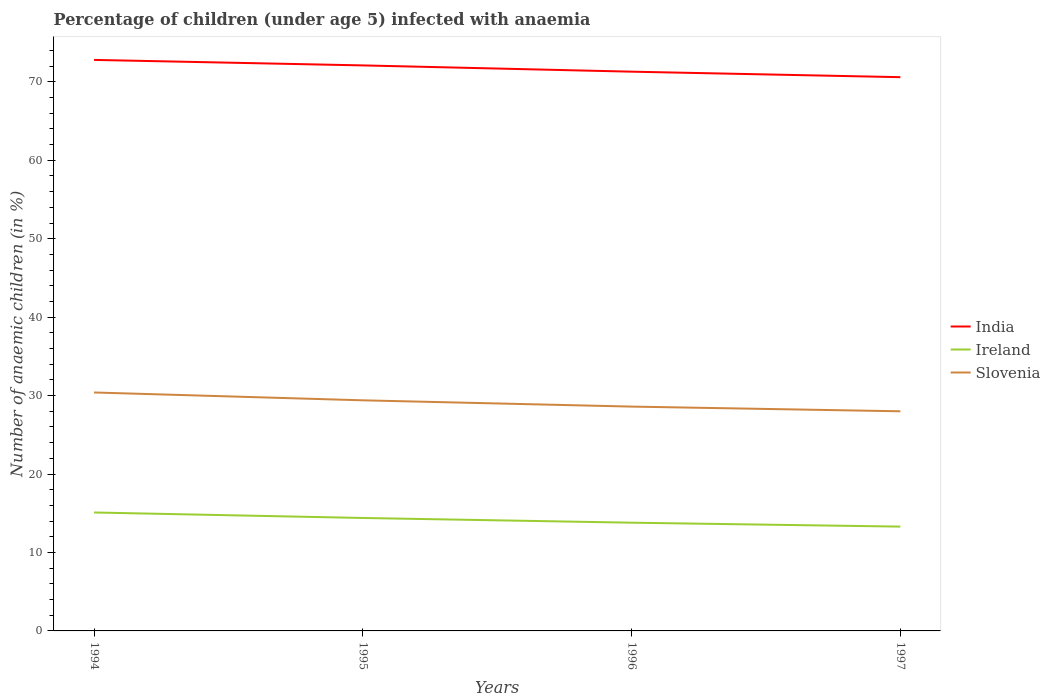How many different coloured lines are there?
Your response must be concise. 3. Does the line corresponding to India intersect with the line corresponding to Ireland?
Offer a very short reply. No. Across all years, what is the maximum percentage of children infected with anaemia in in Slovenia?
Make the answer very short. 28. In which year was the percentage of children infected with anaemia in in Ireland maximum?
Provide a succinct answer. 1997. What is the total percentage of children infected with anaemia in in India in the graph?
Make the answer very short. 0.7. What is the difference between the highest and the second highest percentage of children infected with anaemia in in Slovenia?
Ensure brevity in your answer.  2.4. Is the percentage of children infected with anaemia in in India strictly greater than the percentage of children infected with anaemia in in Ireland over the years?
Offer a very short reply. No. How many lines are there?
Offer a terse response. 3. How many years are there in the graph?
Your response must be concise. 4. Are the values on the major ticks of Y-axis written in scientific E-notation?
Keep it short and to the point. No. Does the graph contain grids?
Give a very brief answer. No. Where does the legend appear in the graph?
Your response must be concise. Center right. What is the title of the graph?
Provide a succinct answer. Percentage of children (under age 5) infected with anaemia. Does "Afghanistan" appear as one of the legend labels in the graph?
Give a very brief answer. No. What is the label or title of the Y-axis?
Give a very brief answer. Number of anaemic children (in %). What is the Number of anaemic children (in %) of India in 1994?
Your answer should be compact. 72.8. What is the Number of anaemic children (in %) in Ireland in 1994?
Offer a very short reply. 15.1. What is the Number of anaemic children (in %) in Slovenia in 1994?
Your response must be concise. 30.4. What is the Number of anaemic children (in %) in India in 1995?
Ensure brevity in your answer.  72.1. What is the Number of anaemic children (in %) of Ireland in 1995?
Provide a short and direct response. 14.4. What is the Number of anaemic children (in %) in Slovenia in 1995?
Your answer should be very brief. 29.4. What is the Number of anaemic children (in %) of India in 1996?
Your answer should be very brief. 71.3. What is the Number of anaemic children (in %) of Slovenia in 1996?
Offer a very short reply. 28.6. What is the Number of anaemic children (in %) of India in 1997?
Ensure brevity in your answer.  70.6. Across all years, what is the maximum Number of anaemic children (in %) of India?
Your answer should be compact. 72.8. Across all years, what is the maximum Number of anaemic children (in %) of Ireland?
Offer a terse response. 15.1. Across all years, what is the maximum Number of anaemic children (in %) in Slovenia?
Keep it short and to the point. 30.4. Across all years, what is the minimum Number of anaemic children (in %) of India?
Your answer should be very brief. 70.6. Across all years, what is the minimum Number of anaemic children (in %) of Ireland?
Your response must be concise. 13.3. Across all years, what is the minimum Number of anaemic children (in %) of Slovenia?
Ensure brevity in your answer.  28. What is the total Number of anaemic children (in %) of India in the graph?
Ensure brevity in your answer.  286.8. What is the total Number of anaemic children (in %) of Ireland in the graph?
Provide a succinct answer. 56.6. What is the total Number of anaemic children (in %) of Slovenia in the graph?
Keep it short and to the point. 116.4. What is the difference between the Number of anaemic children (in %) of Ireland in 1994 and that in 1995?
Provide a succinct answer. 0.7. What is the difference between the Number of anaemic children (in %) of Slovenia in 1994 and that in 1995?
Keep it short and to the point. 1. What is the difference between the Number of anaemic children (in %) in Slovenia in 1994 and that in 1997?
Provide a succinct answer. 2.4. What is the difference between the Number of anaemic children (in %) of Ireland in 1995 and that in 1996?
Provide a short and direct response. 0.6. What is the difference between the Number of anaemic children (in %) in Slovenia in 1995 and that in 1996?
Provide a short and direct response. 0.8. What is the difference between the Number of anaemic children (in %) of India in 1995 and that in 1997?
Keep it short and to the point. 1.5. What is the difference between the Number of anaemic children (in %) of Slovenia in 1995 and that in 1997?
Offer a terse response. 1.4. What is the difference between the Number of anaemic children (in %) in India in 1996 and that in 1997?
Provide a succinct answer. 0.7. What is the difference between the Number of anaemic children (in %) in Ireland in 1996 and that in 1997?
Make the answer very short. 0.5. What is the difference between the Number of anaemic children (in %) of Slovenia in 1996 and that in 1997?
Offer a very short reply. 0.6. What is the difference between the Number of anaemic children (in %) in India in 1994 and the Number of anaemic children (in %) in Ireland in 1995?
Keep it short and to the point. 58.4. What is the difference between the Number of anaemic children (in %) of India in 1994 and the Number of anaemic children (in %) of Slovenia in 1995?
Offer a very short reply. 43.4. What is the difference between the Number of anaemic children (in %) of Ireland in 1994 and the Number of anaemic children (in %) of Slovenia in 1995?
Ensure brevity in your answer.  -14.3. What is the difference between the Number of anaemic children (in %) of India in 1994 and the Number of anaemic children (in %) of Ireland in 1996?
Your response must be concise. 59. What is the difference between the Number of anaemic children (in %) of India in 1994 and the Number of anaemic children (in %) of Slovenia in 1996?
Your response must be concise. 44.2. What is the difference between the Number of anaemic children (in %) of India in 1994 and the Number of anaemic children (in %) of Ireland in 1997?
Offer a terse response. 59.5. What is the difference between the Number of anaemic children (in %) of India in 1994 and the Number of anaemic children (in %) of Slovenia in 1997?
Offer a terse response. 44.8. What is the difference between the Number of anaemic children (in %) in Ireland in 1994 and the Number of anaemic children (in %) in Slovenia in 1997?
Give a very brief answer. -12.9. What is the difference between the Number of anaemic children (in %) in India in 1995 and the Number of anaemic children (in %) in Ireland in 1996?
Provide a short and direct response. 58.3. What is the difference between the Number of anaemic children (in %) of India in 1995 and the Number of anaemic children (in %) of Slovenia in 1996?
Make the answer very short. 43.5. What is the difference between the Number of anaemic children (in %) in India in 1995 and the Number of anaemic children (in %) in Ireland in 1997?
Keep it short and to the point. 58.8. What is the difference between the Number of anaemic children (in %) in India in 1995 and the Number of anaemic children (in %) in Slovenia in 1997?
Ensure brevity in your answer.  44.1. What is the difference between the Number of anaemic children (in %) in Ireland in 1995 and the Number of anaemic children (in %) in Slovenia in 1997?
Your answer should be very brief. -13.6. What is the difference between the Number of anaemic children (in %) in India in 1996 and the Number of anaemic children (in %) in Slovenia in 1997?
Keep it short and to the point. 43.3. What is the difference between the Number of anaemic children (in %) of Ireland in 1996 and the Number of anaemic children (in %) of Slovenia in 1997?
Offer a terse response. -14.2. What is the average Number of anaemic children (in %) of India per year?
Offer a terse response. 71.7. What is the average Number of anaemic children (in %) in Ireland per year?
Provide a short and direct response. 14.15. What is the average Number of anaemic children (in %) of Slovenia per year?
Ensure brevity in your answer.  29.1. In the year 1994, what is the difference between the Number of anaemic children (in %) of India and Number of anaemic children (in %) of Ireland?
Provide a succinct answer. 57.7. In the year 1994, what is the difference between the Number of anaemic children (in %) of India and Number of anaemic children (in %) of Slovenia?
Your answer should be compact. 42.4. In the year 1994, what is the difference between the Number of anaemic children (in %) in Ireland and Number of anaemic children (in %) in Slovenia?
Keep it short and to the point. -15.3. In the year 1995, what is the difference between the Number of anaemic children (in %) in India and Number of anaemic children (in %) in Ireland?
Offer a very short reply. 57.7. In the year 1995, what is the difference between the Number of anaemic children (in %) in India and Number of anaemic children (in %) in Slovenia?
Your answer should be compact. 42.7. In the year 1995, what is the difference between the Number of anaemic children (in %) in Ireland and Number of anaemic children (in %) in Slovenia?
Make the answer very short. -15. In the year 1996, what is the difference between the Number of anaemic children (in %) in India and Number of anaemic children (in %) in Ireland?
Provide a short and direct response. 57.5. In the year 1996, what is the difference between the Number of anaemic children (in %) in India and Number of anaemic children (in %) in Slovenia?
Provide a short and direct response. 42.7. In the year 1996, what is the difference between the Number of anaemic children (in %) of Ireland and Number of anaemic children (in %) of Slovenia?
Your answer should be compact. -14.8. In the year 1997, what is the difference between the Number of anaemic children (in %) of India and Number of anaemic children (in %) of Ireland?
Provide a short and direct response. 57.3. In the year 1997, what is the difference between the Number of anaemic children (in %) of India and Number of anaemic children (in %) of Slovenia?
Provide a short and direct response. 42.6. In the year 1997, what is the difference between the Number of anaemic children (in %) of Ireland and Number of anaemic children (in %) of Slovenia?
Give a very brief answer. -14.7. What is the ratio of the Number of anaemic children (in %) of India in 1994 to that in 1995?
Your response must be concise. 1.01. What is the ratio of the Number of anaemic children (in %) in Ireland in 1994 to that in 1995?
Make the answer very short. 1.05. What is the ratio of the Number of anaemic children (in %) in Slovenia in 1994 to that in 1995?
Keep it short and to the point. 1.03. What is the ratio of the Number of anaemic children (in %) of India in 1994 to that in 1996?
Ensure brevity in your answer.  1.02. What is the ratio of the Number of anaemic children (in %) of Ireland in 1994 to that in 1996?
Your answer should be compact. 1.09. What is the ratio of the Number of anaemic children (in %) in Slovenia in 1994 to that in 1996?
Ensure brevity in your answer.  1.06. What is the ratio of the Number of anaemic children (in %) of India in 1994 to that in 1997?
Offer a very short reply. 1.03. What is the ratio of the Number of anaemic children (in %) of Ireland in 1994 to that in 1997?
Offer a terse response. 1.14. What is the ratio of the Number of anaemic children (in %) in Slovenia in 1994 to that in 1997?
Provide a succinct answer. 1.09. What is the ratio of the Number of anaemic children (in %) in India in 1995 to that in 1996?
Keep it short and to the point. 1.01. What is the ratio of the Number of anaemic children (in %) of Ireland in 1995 to that in 1996?
Your response must be concise. 1.04. What is the ratio of the Number of anaemic children (in %) in Slovenia in 1995 to that in 1996?
Ensure brevity in your answer.  1.03. What is the ratio of the Number of anaemic children (in %) in India in 1995 to that in 1997?
Provide a short and direct response. 1.02. What is the ratio of the Number of anaemic children (in %) of Ireland in 1995 to that in 1997?
Ensure brevity in your answer.  1.08. What is the ratio of the Number of anaemic children (in %) in India in 1996 to that in 1997?
Offer a terse response. 1.01. What is the ratio of the Number of anaemic children (in %) in Ireland in 1996 to that in 1997?
Provide a short and direct response. 1.04. What is the ratio of the Number of anaemic children (in %) of Slovenia in 1996 to that in 1997?
Offer a terse response. 1.02. What is the difference between the highest and the second highest Number of anaemic children (in %) of Slovenia?
Ensure brevity in your answer.  1. What is the difference between the highest and the lowest Number of anaemic children (in %) in India?
Make the answer very short. 2.2. What is the difference between the highest and the lowest Number of anaemic children (in %) in Slovenia?
Provide a succinct answer. 2.4. 